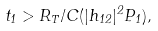Convert formula to latex. <formula><loc_0><loc_0><loc_500><loc_500>t _ { 1 } > R _ { T } / C ( | h _ { 1 2 } | ^ { 2 } P _ { 1 } ) ,</formula> 